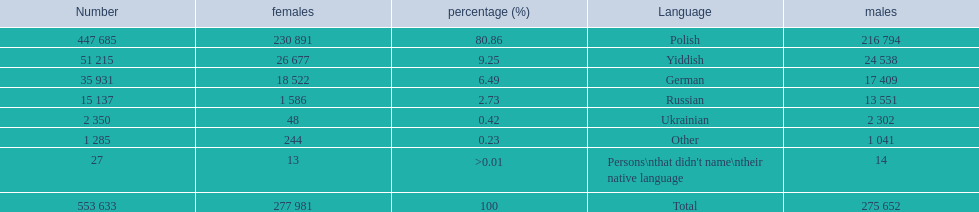What was the highest percentage of one language spoken by the plock governorate? 80.86. What language was spoken by 80.86 percent of the people? Polish. 